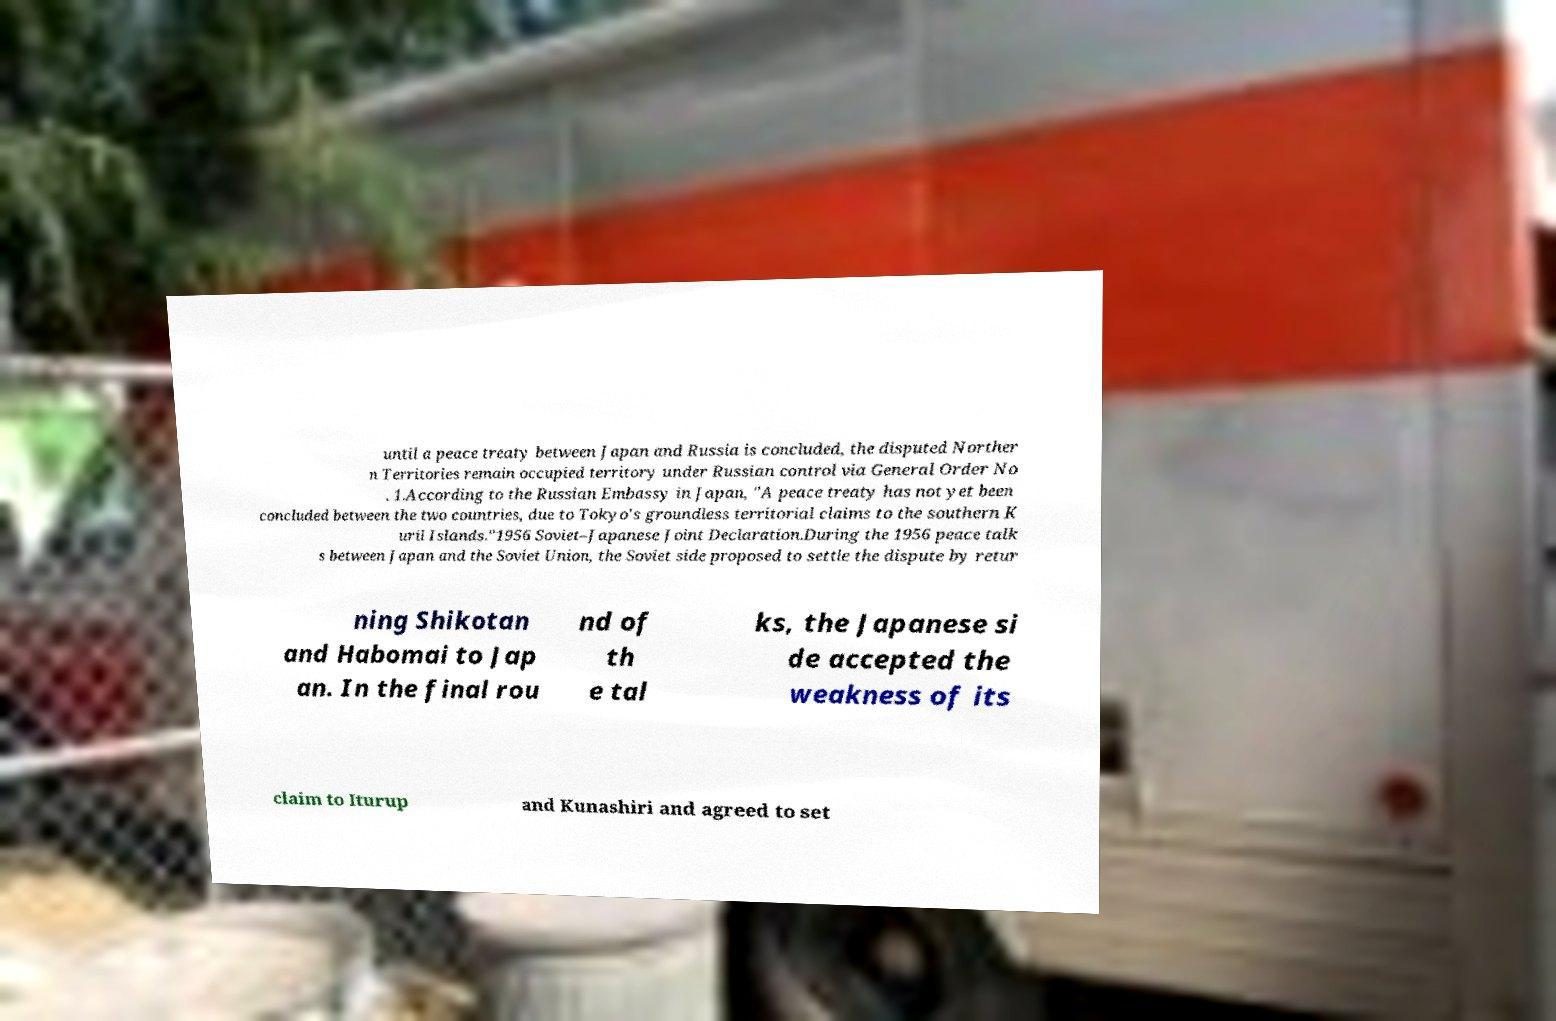There's text embedded in this image that I need extracted. Can you transcribe it verbatim? until a peace treaty between Japan and Russia is concluded, the disputed Norther n Territories remain occupied territory under Russian control via General Order No . 1.According to the Russian Embassy in Japan, "A peace treaty has not yet been concluded between the two countries, due to Tokyo's groundless territorial claims to the southern K uril Islands."1956 Soviet–Japanese Joint Declaration.During the 1956 peace talk s between Japan and the Soviet Union, the Soviet side proposed to settle the dispute by retur ning Shikotan and Habomai to Jap an. In the final rou nd of th e tal ks, the Japanese si de accepted the weakness of its claim to Iturup and Kunashiri and agreed to set 